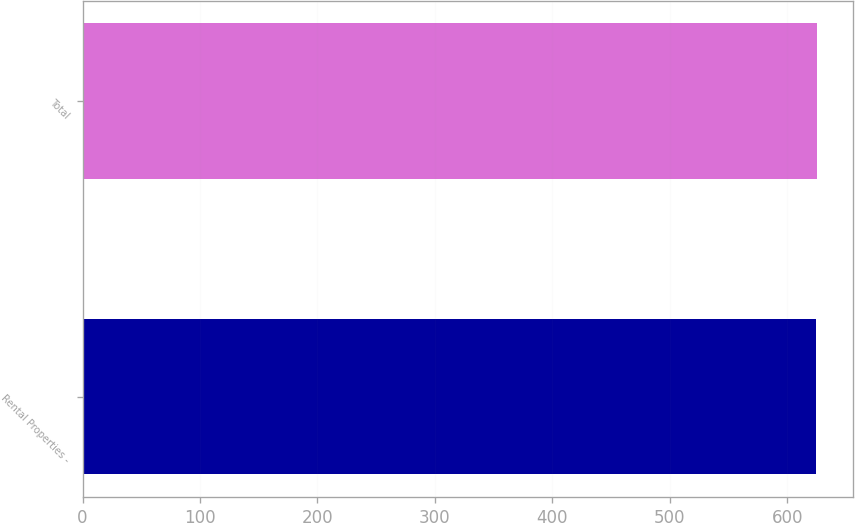Convert chart to OTSL. <chart><loc_0><loc_0><loc_500><loc_500><bar_chart><fcel>Rental Properties -<fcel>Total<nl><fcel>625<fcel>625.1<nl></chart> 